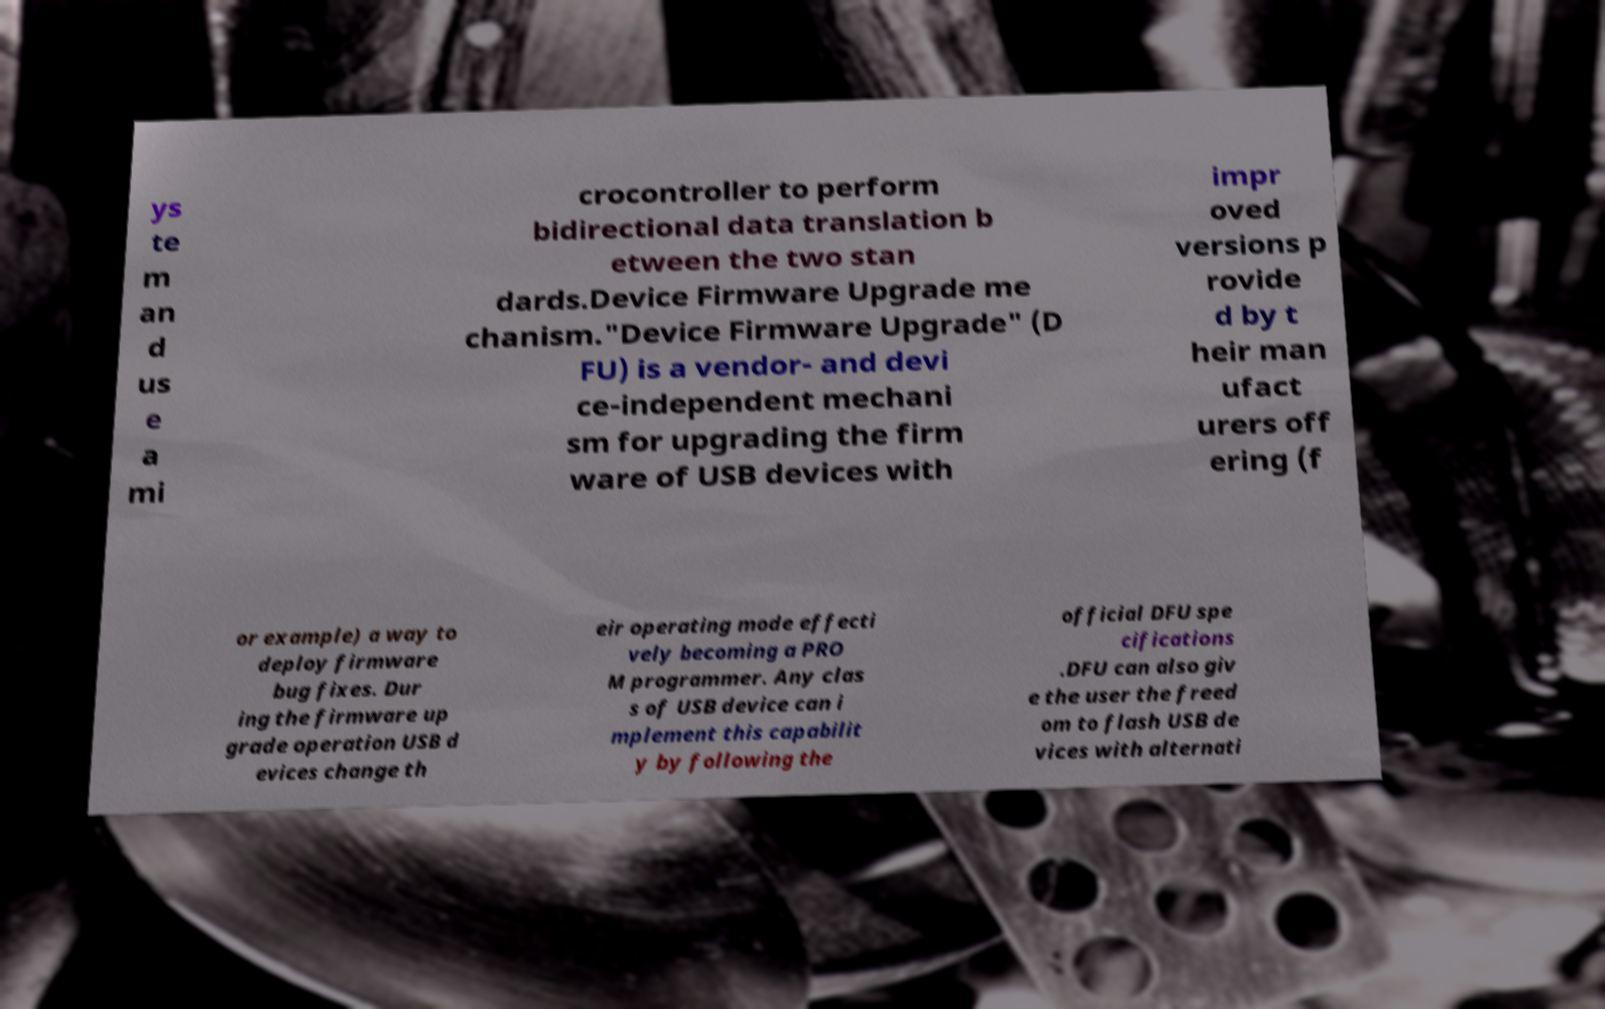Could you assist in decoding the text presented in this image and type it out clearly? ys te m an d us e a mi crocontroller to perform bidirectional data translation b etween the two stan dards.Device Firmware Upgrade me chanism."Device Firmware Upgrade" (D FU) is a vendor- and devi ce-independent mechani sm for upgrading the firm ware of USB devices with impr oved versions p rovide d by t heir man ufact urers off ering (f or example) a way to deploy firmware bug fixes. Dur ing the firmware up grade operation USB d evices change th eir operating mode effecti vely becoming a PRO M programmer. Any clas s of USB device can i mplement this capabilit y by following the official DFU spe cifications .DFU can also giv e the user the freed om to flash USB de vices with alternati 